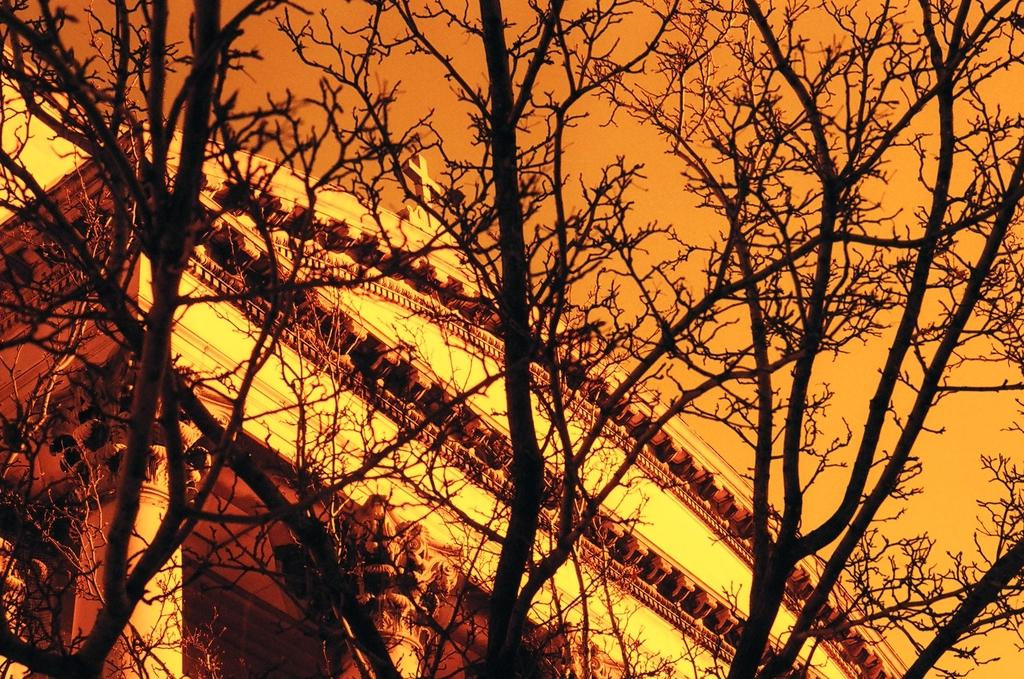What type of structure is present in the image? There is a building in the image. What distinguishing feature can be seen on the building? The building has a cross. What architectural elements are present on the building? The building has pillars. What other natural elements are visible in the image? There are trees in the image. What can be seen in the background of the image? The sky is visible in the image, and it appears cloudy. What type of club can be seen in the image? There is no club present in the image; it features a building with a cross and pillars. What verse is being recited by the trees in the image? There are no verses or any form of recitation associated with the trees in the image. 